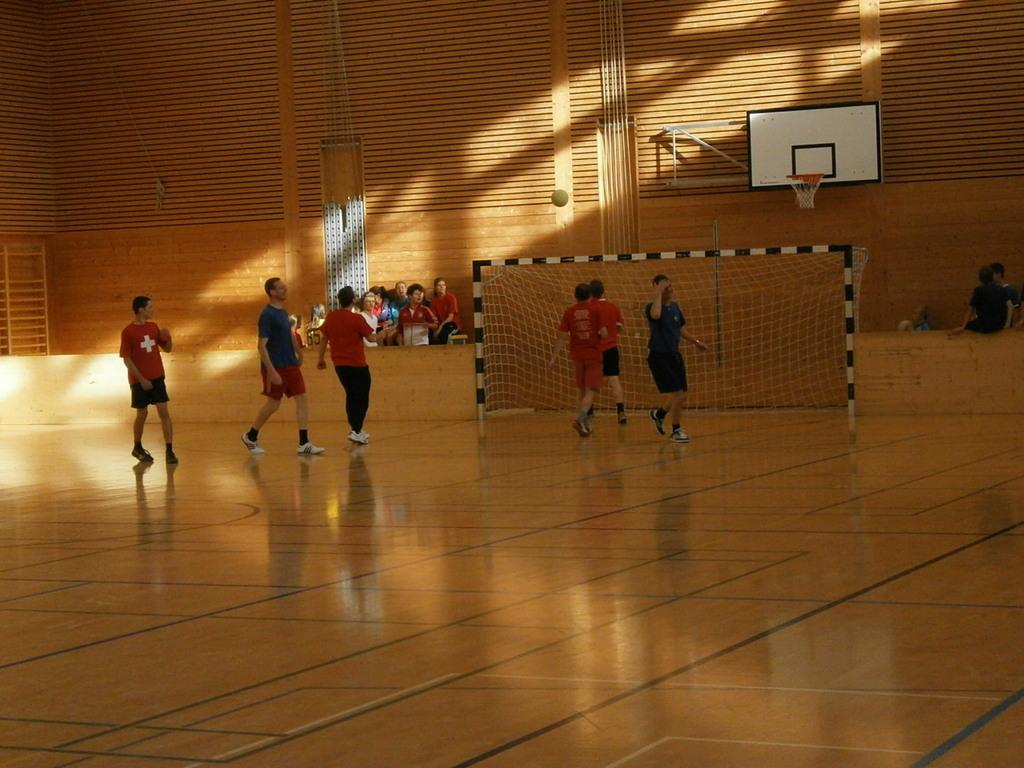What are the people in the image doing? There are people standing on the floor and sitting in the image. What can be seen in the background of the image? There is a net, a basketball court, a wall, and a ladder in the image. What object is present in the image that is commonly used in sports? There is a ball in the image. What type of potato can be seen bouncing on the basketball court in the image? There is no potato present in the image, and therefore no such activity can be observed. What appliance is being used by the people sitting in the image? There is no appliance visible in the image; the people are simply sitting. 